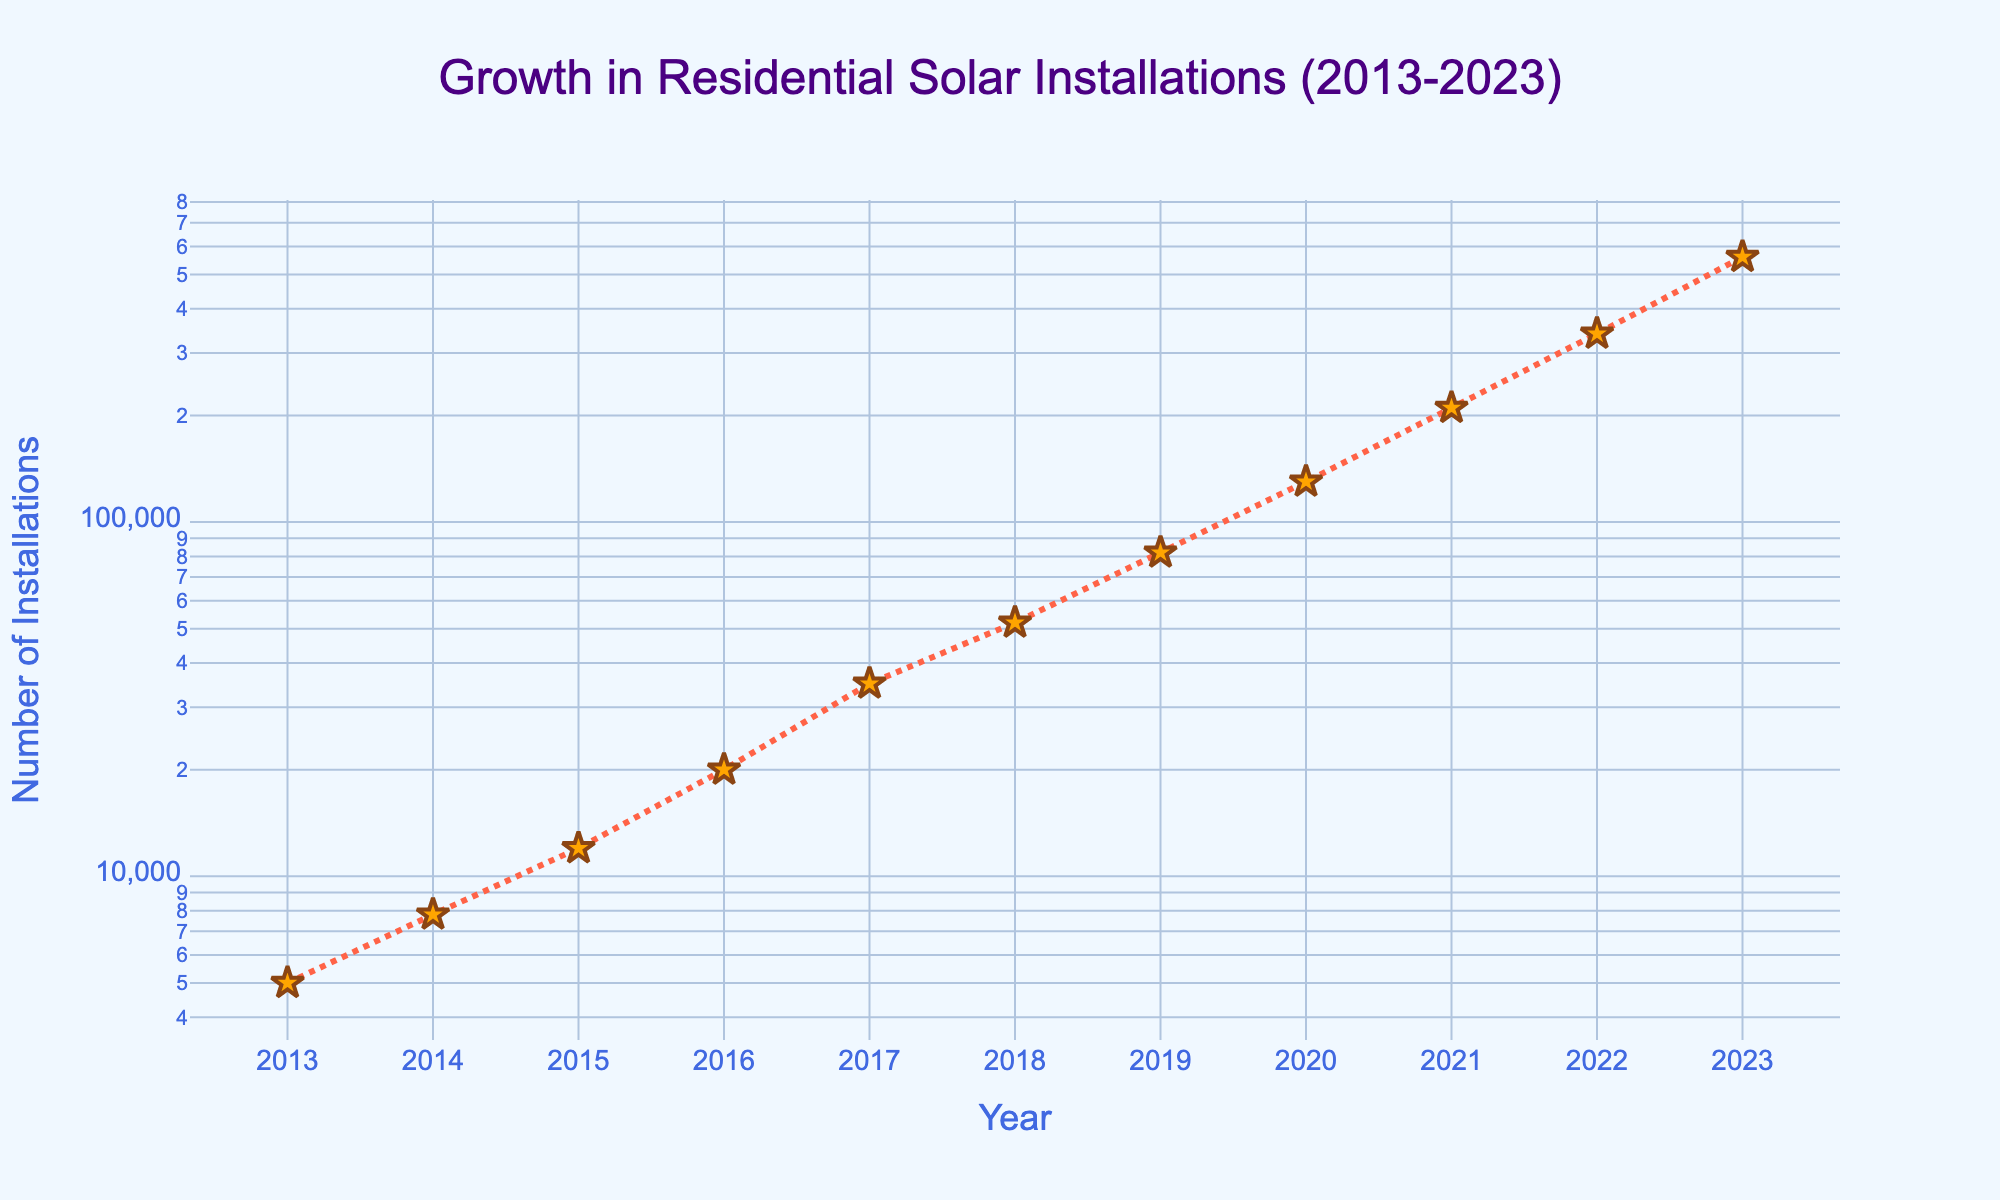what does the title of the plot say? The title is located at the top of the figure. It clearly states "Growth in Residential Solar Installations (2013-2023)." By reading the title, we can understand that the plot shows the growth in the number of residential solar installations over a decade, from 2013 to 2023.
Answer: Growth in Residential Solar Installations (2013-2023) how many data points are shown in the plot? Counting the number of marker points on the plot, each representing an entry for a specific year, reveals there are 11 points. This corresponds to yearly data from 2013 to 2023.
Answer: 11 which year had the lowest number of solar installations? By examining the y-axis (log scale) and noting the position of the data points, the lowest point is around the year 2013, with the number of installations being 5000.
Answer: 2013 how has the number of installations changed between 2016 and 2020? Reading the y-values for 2016 and 2020, we see a significant increase. The installations were 20000 in 2016 and rose to 130000 in 2020. The difference is calculated as 130000 - 20000.
Answer: Increased by 110000 is the growth rate uniform throughout the years? Due to the log scale on the y-axis, we note varying increments. Data points have smaller gaps in some years and larger in others, indicating a non-uniform growth rate, particularly more rapid in recent years.
Answer: No what pattern do you see in the trend of installations from 2013 to 2023? The trend line, especially in a log scale, shows an exponential growth pattern. The markers and lines curve upward steeply, signifying accelerating growth in the number of installations.
Answer: Exponential growth what color are the markers and lines used in the plot? Observing the visual style of the plot, markers are primarily orange with outlines, and the lines connecting them are colored red. These choices help differentiate the data points and make the trend more visible.
Answer: Orange and red comparing 2014 and 2015, which year had more solar installations? By closely examining the plot, we can see the data point for 2015 is higher than for 2014. Numerically, 2014 had 7800 installations, while 2015 had 12000.
Answer: 2015 what annotation is added to the plot and where is it located? There is a textual annotation that reads "Exponential growth!" next to the data point for 2023 (560000 installations). It includes an arrow pointing to this final data point.
Answer: Exponential growth! at 2023 how do installations in 2023 compare to those in 2017? Visually and numerically comparing these data points, installations in 2023 (560000) far exceed those in 2017 (35000). The difference is substantial, indicating major growth over these six years.
Answer: Significantly higher in 2023 